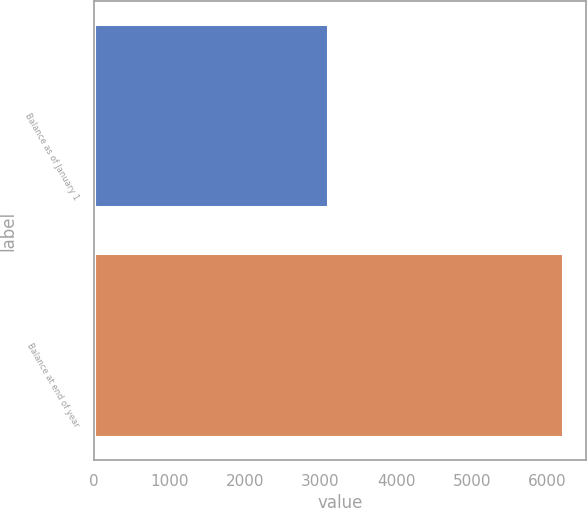Convert chart to OTSL. <chart><loc_0><loc_0><loc_500><loc_500><bar_chart><fcel>Balance as of January 1<fcel>Balance at end of year<nl><fcel>3099.4<fcel>6202.1<nl></chart> 